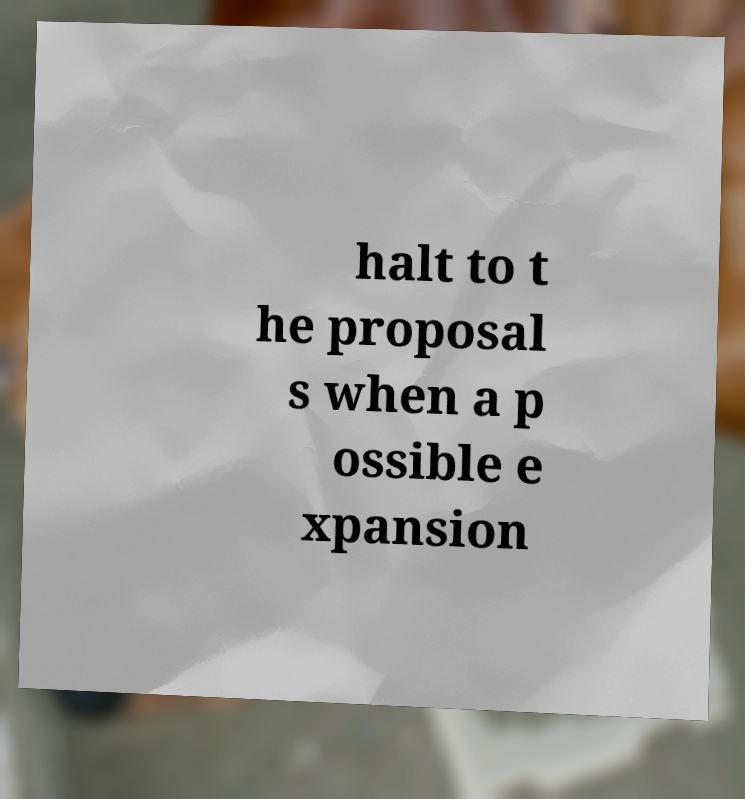Could you extract and type out the text from this image? halt to t he proposal s when a p ossible e xpansion 